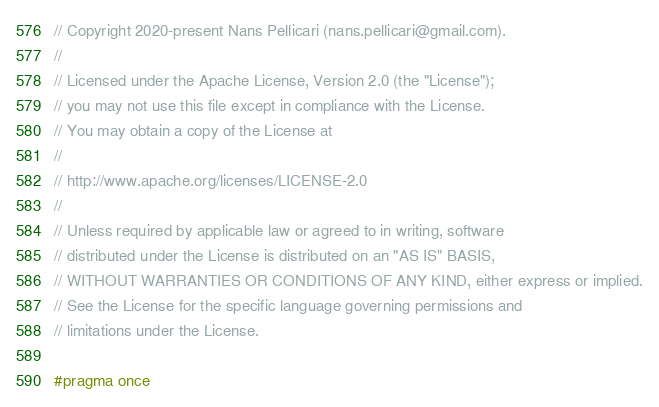Convert code to text. <code><loc_0><loc_0><loc_500><loc_500><_C_>// Copyright 2020-present Nans Pellicari (nans.pellicari@gmail.com).
//
// Licensed under the Apache License, Version 2.0 (the "License");
// you may not use this file except in compliance with the License.
// You may obtain a copy of the License at
//
// http://www.apache.org/licenses/LICENSE-2.0
//
// Unless required by applicable law or agreed to in writing, software
// distributed under the License is distributed on an "AS IS" BASIS,
// WITHOUT WARRANTIES OR CONDITIONS OF ANY KIND, either express or implied.
// See the License for the specific language governing permissions and
// limitations under the License.

#pragma once
</code> 